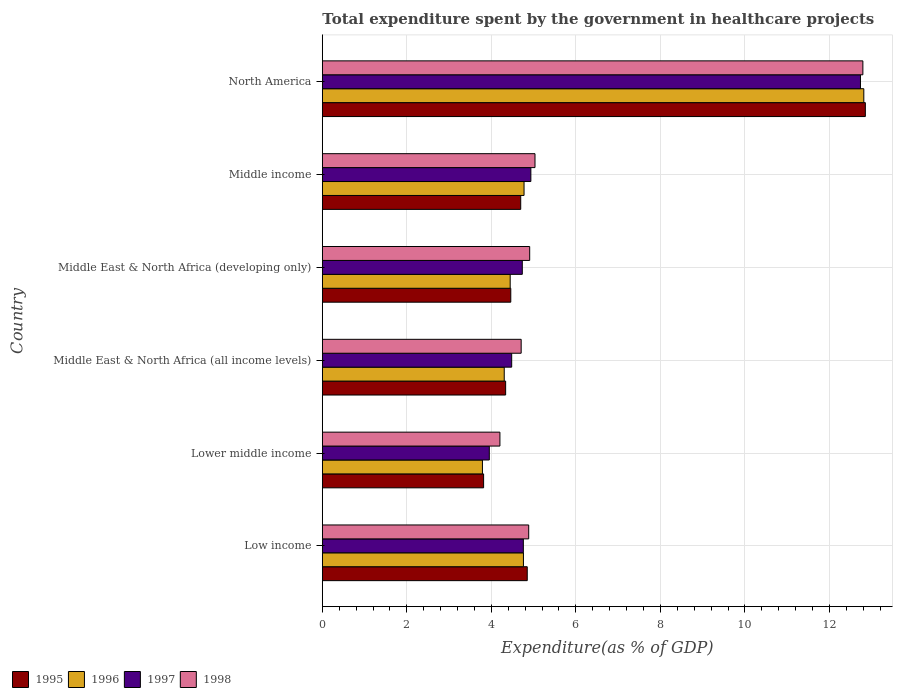How many different coloured bars are there?
Offer a terse response. 4. Are the number of bars on each tick of the Y-axis equal?
Make the answer very short. Yes. What is the label of the 4th group of bars from the top?
Provide a succinct answer. Middle East & North Africa (all income levels). In how many cases, is the number of bars for a given country not equal to the number of legend labels?
Keep it short and to the point. 0. What is the total expenditure spent by the government in healthcare projects in 1996 in North America?
Your answer should be very brief. 12.81. Across all countries, what is the maximum total expenditure spent by the government in healthcare projects in 1996?
Offer a terse response. 12.81. Across all countries, what is the minimum total expenditure spent by the government in healthcare projects in 1998?
Give a very brief answer. 4.2. In which country was the total expenditure spent by the government in healthcare projects in 1998 minimum?
Provide a succinct answer. Lower middle income. What is the total total expenditure spent by the government in healthcare projects in 1998 in the graph?
Your answer should be very brief. 36.52. What is the difference between the total expenditure spent by the government in healthcare projects in 1995 in Low income and that in Lower middle income?
Provide a short and direct response. 1.03. What is the difference between the total expenditure spent by the government in healthcare projects in 1996 in Lower middle income and the total expenditure spent by the government in healthcare projects in 1995 in North America?
Make the answer very short. -9.06. What is the average total expenditure spent by the government in healthcare projects in 1995 per country?
Your answer should be very brief. 5.83. What is the difference between the total expenditure spent by the government in healthcare projects in 1998 and total expenditure spent by the government in healthcare projects in 1996 in Middle East & North Africa (all income levels)?
Provide a short and direct response. 0.4. What is the ratio of the total expenditure spent by the government in healthcare projects in 1997 in Middle East & North Africa (all income levels) to that in Middle East & North Africa (developing only)?
Keep it short and to the point. 0.95. Is the total expenditure spent by the government in healthcare projects in 1997 in Middle East & North Africa (developing only) less than that in Middle income?
Offer a very short reply. Yes. Is the difference between the total expenditure spent by the government in healthcare projects in 1998 in Middle East & North Africa (developing only) and Middle income greater than the difference between the total expenditure spent by the government in healthcare projects in 1996 in Middle East & North Africa (developing only) and Middle income?
Keep it short and to the point. Yes. What is the difference between the highest and the second highest total expenditure spent by the government in healthcare projects in 1997?
Ensure brevity in your answer.  7.8. What is the difference between the highest and the lowest total expenditure spent by the government in healthcare projects in 1997?
Provide a succinct answer. 8.78. In how many countries, is the total expenditure spent by the government in healthcare projects in 1997 greater than the average total expenditure spent by the government in healthcare projects in 1997 taken over all countries?
Your response must be concise. 1. Is it the case that in every country, the sum of the total expenditure spent by the government in healthcare projects in 1997 and total expenditure spent by the government in healthcare projects in 1995 is greater than the sum of total expenditure spent by the government in healthcare projects in 1996 and total expenditure spent by the government in healthcare projects in 1998?
Your response must be concise. No. What does the 4th bar from the bottom in Middle East & North Africa (all income levels) represents?
Keep it short and to the point. 1998. Is it the case that in every country, the sum of the total expenditure spent by the government in healthcare projects in 1997 and total expenditure spent by the government in healthcare projects in 1996 is greater than the total expenditure spent by the government in healthcare projects in 1995?
Provide a succinct answer. Yes. How many bars are there?
Make the answer very short. 24. How many countries are there in the graph?
Provide a succinct answer. 6. Are the values on the major ticks of X-axis written in scientific E-notation?
Give a very brief answer. No. Where does the legend appear in the graph?
Ensure brevity in your answer.  Bottom left. How are the legend labels stacked?
Keep it short and to the point. Horizontal. What is the title of the graph?
Your answer should be compact. Total expenditure spent by the government in healthcare projects. What is the label or title of the X-axis?
Offer a terse response. Expenditure(as % of GDP). What is the Expenditure(as % of GDP) of 1995 in Low income?
Your answer should be compact. 4.85. What is the Expenditure(as % of GDP) of 1996 in Low income?
Your answer should be compact. 4.76. What is the Expenditure(as % of GDP) in 1997 in Low income?
Your answer should be very brief. 4.76. What is the Expenditure(as % of GDP) of 1998 in Low income?
Ensure brevity in your answer.  4.88. What is the Expenditure(as % of GDP) of 1995 in Lower middle income?
Your answer should be compact. 3.82. What is the Expenditure(as % of GDP) of 1996 in Lower middle income?
Your answer should be very brief. 3.79. What is the Expenditure(as % of GDP) in 1997 in Lower middle income?
Your answer should be very brief. 3.95. What is the Expenditure(as % of GDP) of 1998 in Lower middle income?
Ensure brevity in your answer.  4.2. What is the Expenditure(as % of GDP) in 1995 in Middle East & North Africa (all income levels)?
Provide a succinct answer. 4.34. What is the Expenditure(as % of GDP) in 1996 in Middle East & North Africa (all income levels)?
Ensure brevity in your answer.  4.3. What is the Expenditure(as % of GDP) of 1997 in Middle East & North Africa (all income levels)?
Give a very brief answer. 4.48. What is the Expenditure(as % of GDP) of 1998 in Middle East & North Africa (all income levels)?
Ensure brevity in your answer.  4.71. What is the Expenditure(as % of GDP) of 1995 in Middle East & North Africa (developing only)?
Your answer should be very brief. 4.46. What is the Expenditure(as % of GDP) in 1996 in Middle East & North Africa (developing only)?
Your answer should be very brief. 4.45. What is the Expenditure(as % of GDP) of 1997 in Middle East & North Africa (developing only)?
Keep it short and to the point. 4.73. What is the Expenditure(as % of GDP) in 1998 in Middle East & North Africa (developing only)?
Provide a succinct answer. 4.91. What is the Expenditure(as % of GDP) in 1995 in Middle income?
Keep it short and to the point. 4.69. What is the Expenditure(as % of GDP) of 1996 in Middle income?
Your response must be concise. 4.77. What is the Expenditure(as % of GDP) in 1997 in Middle income?
Make the answer very short. 4.93. What is the Expenditure(as % of GDP) in 1998 in Middle income?
Provide a short and direct response. 5.03. What is the Expenditure(as % of GDP) in 1995 in North America?
Your answer should be very brief. 12.85. What is the Expenditure(as % of GDP) of 1996 in North America?
Provide a short and direct response. 12.81. What is the Expenditure(as % of GDP) in 1997 in North America?
Offer a terse response. 12.73. What is the Expenditure(as % of GDP) of 1998 in North America?
Your answer should be compact. 12.79. Across all countries, what is the maximum Expenditure(as % of GDP) of 1995?
Provide a short and direct response. 12.85. Across all countries, what is the maximum Expenditure(as % of GDP) of 1996?
Your answer should be compact. 12.81. Across all countries, what is the maximum Expenditure(as % of GDP) of 1997?
Keep it short and to the point. 12.73. Across all countries, what is the maximum Expenditure(as % of GDP) of 1998?
Ensure brevity in your answer.  12.79. Across all countries, what is the minimum Expenditure(as % of GDP) of 1995?
Your response must be concise. 3.82. Across all countries, what is the minimum Expenditure(as % of GDP) of 1996?
Keep it short and to the point. 3.79. Across all countries, what is the minimum Expenditure(as % of GDP) in 1997?
Ensure brevity in your answer.  3.95. Across all countries, what is the minimum Expenditure(as % of GDP) in 1998?
Keep it short and to the point. 4.2. What is the total Expenditure(as % of GDP) in 1995 in the graph?
Give a very brief answer. 35.01. What is the total Expenditure(as % of GDP) of 1996 in the graph?
Your answer should be compact. 34.88. What is the total Expenditure(as % of GDP) in 1997 in the graph?
Provide a succinct answer. 35.59. What is the total Expenditure(as % of GDP) in 1998 in the graph?
Your answer should be compact. 36.52. What is the difference between the Expenditure(as % of GDP) of 1995 in Low income and that in Lower middle income?
Give a very brief answer. 1.03. What is the difference between the Expenditure(as % of GDP) in 1996 in Low income and that in Lower middle income?
Provide a succinct answer. 0.97. What is the difference between the Expenditure(as % of GDP) of 1997 in Low income and that in Lower middle income?
Give a very brief answer. 0.81. What is the difference between the Expenditure(as % of GDP) in 1998 in Low income and that in Lower middle income?
Make the answer very short. 0.68. What is the difference between the Expenditure(as % of GDP) of 1995 in Low income and that in Middle East & North Africa (all income levels)?
Provide a short and direct response. 0.51. What is the difference between the Expenditure(as % of GDP) of 1996 in Low income and that in Middle East & North Africa (all income levels)?
Keep it short and to the point. 0.45. What is the difference between the Expenditure(as % of GDP) in 1997 in Low income and that in Middle East & North Africa (all income levels)?
Ensure brevity in your answer.  0.28. What is the difference between the Expenditure(as % of GDP) in 1998 in Low income and that in Middle East & North Africa (all income levels)?
Your answer should be compact. 0.18. What is the difference between the Expenditure(as % of GDP) of 1995 in Low income and that in Middle East & North Africa (developing only)?
Provide a short and direct response. 0.39. What is the difference between the Expenditure(as % of GDP) of 1996 in Low income and that in Middle East & North Africa (developing only)?
Provide a short and direct response. 0.31. What is the difference between the Expenditure(as % of GDP) of 1997 in Low income and that in Middle East & North Africa (developing only)?
Give a very brief answer. 0.02. What is the difference between the Expenditure(as % of GDP) of 1998 in Low income and that in Middle East & North Africa (developing only)?
Offer a terse response. -0.02. What is the difference between the Expenditure(as % of GDP) of 1995 in Low income and that in Middle income?
Keep it short and to the point. 0.15. What is the difference between the Expenditure(as % of GDP) in 1996 in Low income and that in Middle income?
Provide a short and direct response. -0.01. What is the difference between the Expenditure(as % of GDP) in 1997 in Low income and that in Middle income?
Provide a succinct answer. -0.18. What is the difference between the Expenditure(as % of GDP) in 1998 in Low income and that in Middle income?
Make the answer very short. -0.15. What is the difference between the Expenditure(as % of GDP) of 1995 in Low income and that in North America?
Give a very brief answer. -8. What is the difference between the Expenditure(as % of GDP) of 1996 in Low income and that in North America?
Give a very brief answer. -8.05. What is the difference between the Expenditure(as % of GDP) of 1997 in Low income and that in North America?
Provide a succinct answer. -7.98. What is the difference between the Expenditure(as % of GDP) in 1998 in Low income and that in North America?
Your response must be concise. -7.91. What is the difference between the Expenditure(as % of GDP) of 1995 in Lower middle income and that in Middle East & North Africa (all income levels)?
Keep it short and to the point. -0.52. What is the difference between the Expenditure(as % of GDP) in 1996 in Lower middle income and that in Middle East & North Africa (all income levels)?
Make the answer very short. -0.52. What is the difference between the Expenditure(as % of GDP) in 1997 in Lower middle income and that in Middle East & North Africa (all income levels)?
Offer a very short reply. -0.53. What is the difference between the Expenditure(as % of GDP) in 1998 in Lower middle income and that in Middle East & North Africa (all income levels)?
Offer a terse response. -0.5. What is the difference between the Expenditure(as % of GDP) of 1995 in Lower middle income and that in Middle East & North Africa (developing only)?
Your answer should be compact. -0.64. What is the difference between the Expenditure(as % of GDP) in 1996 in Lower middle income and that in Middle East & North Africa (developing only)?
Keep it short and to the point. -0.66. What is the difference between the Expenditure(as % of GDP) of 1997 in Lower middle income and that in Middle East & North Africa (developing only)?
Give a very brief answer. -0.78. What is the difference between the Expenditure(as % of GDP) in 1998 in Lower middle income and that in Middle East & North Africa (developing only)?
Your response must be concise. -0.7. What is the difference between the Expenditure(as % of GDP) of 1995 in Lower middle income and that in Middle income?
Your response must be concise. -0.88. What is the difference between the Expenditure(as % of GDP) in 1996 in Lower middle income and that in Middle income?
Give a very brief answer. -0.98. What is the difference between the Expenditure(as % of GDP) in 1997 in Lower middle income and that in Middle income?
Provide a short and direct response. -0.98. What is the difference between the Expenditure(as % of GDP) of 1998 in Lower middle income and that in Middle income?
Offer a terse response. -0.83. What is the difference between the Expenditure(as % of GDP) in 1995 in Lower middle income and that in North America?
Make the answer very short. -9.03. What is the difference between the Expenditure(as % of GDP) in 1996 in Lower middle income and that in North America?
Ensure brevity in your answer.  -9.02. What is the difference between the Expenditure(as % of GDP) in 1997 in Lower middle income and that in North America?
Make the answer very short. -8.78. What is the difference between the Expenditure(as % of GDP) of 1998 in Lower middle income and that in North America?
Your response must be concise. -8.59. What is the difference between the Expenditure(as % of GDP) in 1995 in Middle East & North Africa (all income levels) and that in Middle East & North Africa (developing only)?
Your answer should be very brief. -0.12. What is the difference between the Expenditure(as % of GDP) of 1996 in Middle East & North Africa (all income levels) and that in Middle East & North Africa (developing only)?
Provide a succinct answer. -0.14. What is the difference between the Expenditure(as % of GDP) of 1997 in Middle East & North Africa (all income levels) and that in Middle East & North Africa (developing only)?
Keep it short and to the point. -0.25. What is the difference between the Expenditure(as % of GDP) in 1998 in Middle East & North Africa (all income levels) and that in Middle East & North Africa (developing only)?
Your response must be concise. -0.2. What is the difference between the Expenditure(as % of GDP) of 1995 in Middle East & North Africa (all income levels) and that in Middle income?
Your answer should be compact. -0.36. What is the difference between the Expenditure(as % of GDP) of 1996 in Middle East & North Africa (all income levels) and that in Middle income?
Your response must be concise. -0.47. What is the difference between the Expenditure(as % of GDP) in 1997 in Middle East & North Africa (all income levels) and that in Middle income?
Ensure brevity in your answer.  -0.45. What is the difference between the Expenditure(as % of GDP) in 1998 in Middle East & North Africa (all income levels) and that in Middle income?
Make the answer very short. -0.33. What is the difference between the Expenditure(as % of GDP) in 1995 in Middle East & North Africa (all income levels) and that in North America?
Your answer should be compact. -8.51. What is the difference between the Expenditure(as % of GDP) of 1996 in Middle East & North Africa (all income levels) and that in North America?
Your answer should be compact. -8.51. What is the difference between the Expenditure(as % of GDP) in 1997 in Middle East & North Africa (all income levels) and that in North America?
Ensure brevity in your answer.  -8.25. What is the difference between the Expenditure(as % of GDP) of 1998 in Middle East & North Africa (all income levels) and that in North America?
Offer a very short reply. -8.09. What is the difference between the Expenditure(as % of GDP) of 1995 in Middle East & North Africa (developing only) and that in Middle income?
Provide a short and direct response. -0.24. What is the difference between the Expenditure(as % of GDP) in 1996 in Middle East & North Africa (developing only) and that in Middle income?
Keep it short and to the point. -0.33. What is the difference between the Expenditure(as % of GDP) in 1997 in Middle East & North Africa (developing only) and that in Middle income?
Ensure brevity in your answer.  -0.2. What is the difference between the Expenditure(as % of GDP) of 1998 in Middle East & North Africa (developing only) and that in Middle income?
Provide a succinct answer. -0.13. What is the difference between the Expenditure(as % of GDP) of 1995 in Middle East & North Africa (developing only) and that in North America?
Give a very brief answer. -8.39. What is the difference between the Expenditure(as % of GDP) in 1996 in Middle East & North Africa (developing only) and that in North America?
Your response must be concise. -8.37. What is the difference between the Expenditure(as % of GDP) in 1997 in Middle East & North Africa (developing only) and that in North America?
Ensure brevity in your answer.  -8. What is the difference between the Expenditure(as % of GDP) of 1998 in Middle East & North Africa (developing only) and that in North America?
Provide a succinct answer. -7.88. What is the difference between the Expenditure(as % of GDP) of 1995 in Middle income and that in North America?
Keep it short and to the point. -8.15. What is the difference between the Expenditure(as % of GDP) of 1996 in Middle income and that in North America?
Ensure brevity in your answer.  -8.04. What is the difference between the Expenditure(as % of GDP) of 1997 in Middle income and that in North America?
Make the answer very short. -7.8. What is the difference between the Expenditure(as % of GDP) in 1998 in Middle income and that in North America?
Your answer should be compact. -7.76. What is the difference between the Expenditure(as % of GDP) in 1995 in Low income and the Expenditure(as % of GDP) in 1996 in Lower middle income?
Give a very brief answer. 1.06. What is the difference between the Expenditure(as % of GDP) of 1995 in Low income and the Expenditure(as % of GDP) of 1997 in Lower middle income?
Ensure brevity in your answer.  0.9. What is the difference between the Expenditure(as % of GDP) in 1995 in Low income and the Expenditure(as % of GDP) in 1998 in Lower middle income?
Your answer should be compact. 0.65. What is the difference between the Expenditure(as % of GDP) of 1996 in Low income and the Expenditure(as % of GDP) of 1997 in Lower middle income?
Give a very brief answer. 0.81. What is the difference between the Expenditure(as % of GDP) of 1996 in Low income and the Expenditure(as % of GDP) of 1998 in Lower middle income?
Offer a terse response. 0.56. What is the difference between the Expenditure(as % of GDP) of 1997 in Low income and the Expenditure(as % of GDP) of 1998 in Lower middle income?
Your answer should be very brief. 0.55. What is the difference between the Expenditure(as % of GDP) in 1995 in Low income and the Expenditure(as % of GDP) in 1996 in Middle East & North Africa (all income levels)?
Offer a very short reply. 0.54. What is the difference between the Expenditure(as % of GDP) in 1995 in Low income and the Expenditure(as % of GDP) in 1997 in Middle East & North Africa (all income levels)?
Offer a very short reply. 0.37. What is the difference between the Expenditure(as % of GDP) of 1995 in Low income and the Expenditure(as % of GDP) of 1998 in Middle East & North Africa (all income levels)?
Your answer should be very brief. 0.14. What is the difference between the Expenditure(as % of GDP) in 1996 in Low income and the Expenditure(as % of GDP) in 1997 in Middle East & North Africa (all income levels)?
Keep it short and to the point. 0.28. What is the difference between the Expenditure(as % of GDP) in 1996 in Low income and the Expenditure(as % of GDP) in 1998 in Middle East & North Africa (all income levels)?
Your response must be concise. 0.05. What is the difference between the Expenditure(as % of GDP) in 1997 in Low income and the Expenditure(as % of GDP) in 1998 in Middle East & North Africa (all income levels)?
Provide a short and direct response. 0.05. What is the difference between the Expenditure(as % of GDP) of 1995 in Low income and the Expenditure(as % of GDP) of 1996 in Middle East & North Africa (developing only)?
Make the answer very short. 0.4. What is the difference between the Expenditure(as % of GDP) in 1995 in Low income and the Expenditure(as % of GDP) in 1997 in Middle East & North Africa (developing only)?
Provide a short and direct response. 0.12. What is the difference between the Expenditure(as % of GDP) of 1995 in Low income and the Expenditure(as % of GDP) of 1998 in Middle East & North Africa (developing only)?
Your response must be concise. -0.06. What is the difference between the Expenditure(as % of GDP) of 1996 in Low income and the Expenditure(as % of GDP) of 1997 in Middle East & North Africa (developing only)?
Provide a short and direct response. 0.03. What is the difference between the Expenditure(as % of GDP) of 1996 in Low income and the Expenditure(as % of GDP) of 1998 in Middle East & North Africa (developing only)?
Ensure brevity in your answer.  -0.15. What is the difference between the Expenditure(as % of GDP) of 1997 in Low income and the Expenditure(as % of GDP) of 1998 in Middle East & North Africa (developing only)?
Provide a short and direct response. -0.15. What is the difference between the Expenditure(as % of GDP) in 1995 in Low income and the Expenditure(as % of GDP) in 1996 in Middle income?
Provide a short and direct response. 0.08. What is the difference between the Expenditure(as % of GDP) in 1995 in Low income and the Expenditure(as % of GDP) in 1997 in Middle income?
Keep it short and to the point. -0.09. What is the difference between the Expenditure(as % of GDP) of 1995 in Low income and the Expenditure(as % of GDP) of 1998 in Middle income?
Ensure brevity in your answer.  -0.18. What is the difference between the Expenditure(as % of GDP) of 1996 in Low income and the Expenditure(as % of GDP) of 1997 in Middle income?
Your response must be concise. -0.18. What is the difference between the Expenditure(as % of GDP) of 1996 in Low income and the Expenditure(as % of GDP) of 1998 in Middle income?
Your answer should be compact. -0.27. What is the difference between the Expenditure(as % of GDP) in 1997 in Low income and the Expenditure(as % of GDP) in 1998 in Middle income?
Your response must be concise. -0.28. What is the difference between the Expenditure(as % of GDP) of 1995 in Low income and the Expenditure(as % of GDP) of 1996 in North America?
Make the answer very short. -7.96. What is the difference between the Expenditure(as % of GDP) in 1995 in Low income and the Expenditure(as % of GDP) in 1997 in North America?
Ensure brevity in your answer.  -7.88. What is the difference between the Expenditure(as % of GDP) in 1995 in Low income and the Expenditure(as % of GDP) in 1998 in North America?
Offer a terse response. -7.94. What is the difference between the Expenditure(as % of GDP) in 1996 in Low income and the Expenditure(as % of GDP) in 1997 in North America?
Your answer should be very brief. -7.97. What is the difference between the Expenditure(as % of GDP) of 1996 in Low income and the Expenditure(as % of GDP) of 1998 in North America?
Your response must be concise. -8.03. What is the difference between the Expenditure(as % of GDP) of 1997 in Low income and the Expenditure(as % of GDP) of 1998 in North America?
Offer a very short reply. -8.03. What is the difference between the Expenditure(as % of GDP) of 1995 in Lower middle income and the Expenditure(as % of GDP) of 1996 in Middle East & North Africa (all income levels)?
Give a very brief answer. -0.49. What is the difference between the Expenditure(as % of GDP) of 1995 in Lower middle income and the Expenditure(as % of GDP) of 1997 in Middle East & North Africa (all income levels)?
Your answer should be very brief. -0.66. What is the difference between the Expenditure(as % of GDP) in 1995 in Lower middle income and the Expenditure(as % of GDP) in 1998 in Middle East & North Africa (all income levels)?
Your response must be concise. -0.89. What is the difference between the Expenditure(as % of GDP) in 1996 in Lower middle income and the Expenditure(as % of GDP) in 1997 in Middle East & North Africa (all income levels)?
Give a very brief answer. -0.69. What is the difference between the Expenditure(as % of GDP) in 1996 in Lower middle income and the Expenditure(as % of GDP) in 1998 in Middle East & North Africa (all income levels)?
Your response must be concise. -0.92. What is the difference between the Expenditure(as % of GDP) in 1997 in Lower middle income and the Expenditure(as % of GDP) in 1998 in Middle East & North Africa (all income levels)?
Give a very brief answer. -0.75. What is the difference between the Expenditure(as % of GDP) in 1995 in Lower middle income and the Expenditure(as % of GDP) in 1996 in Middle East & North Africa (developing only)?
Keep it short and to the point. -0.63. What is the difference between the Expenditure(as % of GDP) in 1995 in Lower middle income and the Expenditure(as % of GDP) in 1997 in Middle East & North Africa (developing only)?
Provide a short and direct response. -0.92. What is the difference between the Expenditure(as % of GDP) of 1995 in Lower middle income and the Expenditure(as % of GDP) of 1998 in Middle East & North Africa (developing only)?
Your answer should be very brief. -1.09. What is the difference between the Expenditure(as % of GDP) of 1996 in Lower middle income and the Expenditure(as % of GDP) of 1997 in Middle East & North Africa (developing only)?
Ensure brevity in your answer.  -0.94. What is the difference between the Expenditure(as % of GDP) of 1996 in Lower middle income and the Expenditure(as % of GDP) of 1998 in Middle East & North Africa (developing only)?
Provide a succinct answer. -1.12. What is the difference between the Expenditure(as % of GDP) in 1997 in Lower middle income and the Expenditure(as % of GDP) in 1998 in Middle East & North Africa (developing only)?
Keep it short and to the point. -0.96. What is the difference between the Expenditure(as % of GDP) of 1995 in Lower middle income and the Expenditure(as % of GDP) of 1996 in Middle income?
Your answer should be very brief. -0.96. What is the difference between the Expenditure(as % of GDP) of 1995 in Lower middle income and the Expenditure(as % of GDP) of 1997 in Middle income?
Ensure brevity in your answer.  -1.12. What is the difference between the Expenditure(as % of GDP) in 1995 in Lower middle income and the Expenditure(as % of GDP) in 1998 in Middle income?
Offer a very short reply. -1.22. What is the difference between the Expenditure(as % of GDP) in 1996 in Lower middle income and the Expenditure(as % of GDP) in 1997 in Middle income?
Your response must be concise. -1.15. What is the difference between the Expenditure(as % of GDP) in 1996 in Lower middle income and the Expenditure(as % of GDP) in 1998 in Middle income?
Offer a terse response. -1.24. What is the difference between the Expenditure(as % of GDP) in 1997 in Lower middle income and the Expenditure(as % of GDP) in 1998 in Middle income?
Your response must be concise. -1.08. What is the difference between the Expenditure(as % of GDP) in 1995 in Lower middle income and the Expenditure(as % of GDP) in 1996 in North America?
Provide a short and direct response. -9. What is the difference between the Expenditure(as % of GDP) of 1995 in Lower middle income and the Expenditure(as % of GDP) of 1997 in North America?
Your answer should be compact. -8.92. What is the difference between the Expenditure(as % of GDP) of 1995 in Lower middle income and the Expenditure(as % of GDP) of 1998 in North America?
Your answer should be compact. -8.97. What is the difference between the Expenditure(as % of GDP) in 1996 in Lower middle income and the Expenditure(as % of GDP) in 1997 in North America?
Your response must be concise. -8.95. What is the difference between the Expenditure(as % of GDP) in 1996 in Lower middle income and the Expenditure(as % of GDP) in 1998 in North America?
Your answer should be very brief. -9. What is the difference between the Expenditure(as % of GDP) in 1997 in Lower middle income and the Expenditure(as % of GDP) in 1998 in North America?
Your answer should be compact. -8.84. What is the difference between the Expenditure(as % of GDP) of 1995 in Middle East & North Africa (all income levels) and the Expenditure(as % of GDP) of 1996 in Middle East & North Africa (developing only)?
Give a very brief answer. -0.11. What is the difference between the Expenditure(as % of GDP) in 1995 in Middle East & North Africa (all income levels) and the Expenditure(as % of GDP) in 1997 in Middle East & North Africa (developing only)?
Offer a very short reply. -0.39. What is the difference between the Expenditure(as % of GDP) of 1995 in Middle East & North Africa (all income levels) and the Expenditure(as % of GDP) of 1998 in Middle East & North Africa (developing only)?
Provide a succinct answer. -0.57. What is the difference between the Expenditure(as % of GDP) of 1996 in Middle East & North Africa (all income levels) and the Expenditure(as % of GDP) of 1997 in Middle East & North Africa (developing only)?
Make the answer very short. -0.43. What is the difference between the Expenditure(as % of GDP) in 1996 in Middle East & North Africa (all income levels) and the Expenditure(as % of GDP) in 1998 in Middle East & North Africa (developing only)?
Your answer should be compact. -0.6. What is the difference between the Expenditure(as % of GDP) in 1997 in Middle East & North Africa (all income levels) and the Expenditure(as % of GDP) in 1998 in Middle East & North Africa (developing only)?
Offer a terse response. -0.43. What is the difference between the Expenditure(as % of GDP) in 1995 in Middle East & North Africa (all income levels) and the Expenditure(as % of GDP) in 1996 in Middle income?
Ensure brevity in your answer.  -0.44. What is the difference between the Expenditure(as % of GDP) in 1995 in Middle East & North Africa (all income levels) and the Expenditure(as % of GDP) in 1997 in Middle income?
Provide a succinct answer. -0.6. What is the difference between the Expenditure(as % of GDP) of 1995 in Middle East & North Africa (all income levels) and the Expenditure(as % of GDP) of 1998 in Middle income?
Provide a short and direct response. -0.69. What is the difference between the Expenditure(as % of GDP) in 1996 in Middle East & North Africa (all income levels) and the Expenditure(as % of GDP) in 1997 in Middle income?
Your response must be concise. -0.63. What is the difference between the Expenditure(as % of GDP) in 1996 in Middle East & North Africa (all income levels) and the Expenditure(as % of GDP) in 1998 in Middle income?
Provide a succinct answer. -0.73. What is the difference between the Expenditure(as % of GDP) in 1997 in Middle East & North Africa (all income levels) and the Expenditure(as % of GDP) in 1998 in Middle income?
Ensure brevity in your answer.  -0.55. What is the difference between the Expenditure(as % of GDP) in 1995 in Middle East & North Africa (all income levels) and the Expenditure(as % of GDP) in 1996 in North America?
Your answer should be very brief. -8.48. What is the difference between the Expenditure(as % of GDP) of 1995 in Middle East & North Africa (all income levels) and the Expenditure(as % of GDP) of 1997 in North America?
Give a very brief answer. -8.4. What is the difference between the Expenditure(as % of GDP) of 1995 in Middle East & North Africa (all income levels) and the Expenditure(as % of GDP) of 1998 in North America?
Provide a short and direct response. -8.45. What is the difference between the Expenditure(as % of GDP) in 1996 in Middle East & North Africa (all income levels) and the Expenditure(as % of GDP) in 1997 in North America?
Your answer should be very brief. -8.43. What is the difference between the Expenditure(as % of GDP) in 1996 in Middle East & North Africa (all income levels) and the Expenditure(as % of GDP) in 1998 in North America?
Your answer should be very brief. -8.49. What is the difference between the Expenditure(as % of GDP) in 1997 in Middle East & North Africa (all income levels) and the Expenditure(as % of GDP) in 1998 in North America?
Offer a very short reply. -8.31. What is the difference between the Expenditure(as % of GDP) in 1995 in Middle East & North Africa (developing only) and the Expenditure(as % of GDP) in 1996 in Middle income?
Keep it short and to the point. -0.31. What is the difference between the Expenditure(as % of GDP) of 1995 in Middle East & North Africa (developing only) and the Expenditure(as % of GDP) of 1997 in Middle income?
Offer a very short reply. -0.48. What is the difference between the Expenditure(as % of GDP) in 1995 in Middle East & North Africa (developing only) and the Expenditure(as % of GDP) in 1998 in Middle income?
Make the answer very short. -0.57. What is the difference between the Expenditure(as % of GDP) of 1996 in Middle East & North Africa (developing only) and the Expenditure(as % of GDP) of 1997 in Middle income?
Provide a short and direct response. -0.49. What is the difference between the Expenditure(as % of GDP) in 1996 in Middle East & North Africa (developing only) and the Expenditure(as % of GDP) in 1998 in Middle income?
Make the answer very short. -0.59. What is the difference between the Expenditure(as % of GDP) in 1997 in Middle East & North Africa (developing only) and the Expenditure(as % of GDP) in 1998 in Middle income?
Offer a very short reply. -0.3. What is the difference between the Expenditure(as % of GDP) in 1995 in Middle East & North Africa (developing only) and the Expenditure(as % of GDP) in 1996 in North America?
Give a very brief answer. -8.35. What is the difference between the Expenditure(as % of GDP) in 1995 in Middle East & North Africa (developing only) and the Expenditure(as % of GDP) in 1997 in North America?
Your answer should be compact. -8.27. What is the difference between the Expenditure(as % of GDP) in 1995 in Middle East & North Africa (developing only) and the Expenditure(as % of GDP) in 1998 in North America?
Provide a succinct answer. -8.33. What is the difference between the Expenditure(as % of GDP) of 1996 in Middle East & North Africa (developing only) and the Expenditure(as % of GDP) of 1997 in North America?
Offer a terse response. -8.29. What is the difference between the Expenditure(as % of GDP) in 1996 in Middle East & North Africa (developing only) and the Expenditure(as % of GDP) in 1998 in North America?
Give a very brief answer. -8.35. What is the difference between the Expenditure(as % of GDP) in 1997 in Middle East & North Africa (developing only) and the Expenditure(as % of GDP) in 1998 in North America?
Provide a short and direct response. -8.06. What is the difference between the Expenditure(as % of GDP) in 1995 in Middle income and the Expenditure(as % of GDP) in 1996 in North America?
Your answer should be very brief. -8.12. What is the difference between the Expenditure(as % of GDP) in 1995 in Middle income and the Expenditure(as % of GDP) in 1997 in North America?
Make the answer very short. -8.04. What is the difference between the Expenditure(as % of GDP) of 1995 in Middle income and the Expenditure(as % of GDP) of 1998 in North America?
Make the answer very short. -8.1. What is the difference between the Expenditure(as % of GDP) of 1996 in Middle income and the Expenditure(as % of GDP) of 1997 in North America?
Offer a very short reply. -7.96. What is the difference between the Expenditure(as % of GDP) in 1996 in Middle income and the Expenditure(as % of GDP) in 1998 in North America?
Give a very brief answer. -8.02. What is the difference between the Expenditure(as % of GDP) of 1997 in Middle income and the Expenditure(as % of GDP) of 1998 in North America?
Offer a very short reply. -7.86. What is the average Expenditure(as % of GDP) of 1995 per country?
Your response must be concise. 5.83. What is the average Expenditure(as % of GDP) in 1996 per country?
Your answer should be very brief. 5.81. What is the average Expenditure(as % of GDP) of 1997 per country?
Keep it short and to the point. 5.93. What is the average Expenditure(as % of GDP) in 1998 per country?
Provide a succinct answer. 6.09. What is the difference between the Expenditure(as % of GDP) of 1995 and Expenditure(as % of GDP) of 1996 in Low income?
Give a very brief answer. 0.09. What is the difference between the Expenditure(as % of GDP) of 1995 and Expenditure(as % of GDP) of 1997 in Low income?
Offer a very short reply. 0.09. What is the difference between the Expenditure(as % of GDP) of 1995 and Expenditure(as % of GDP) of 1998 in Low income?
Keep it short and to the point. -0.03. What is the difference between the Expenditure(as % of GDP) of 1996 and Expenditure(as % of GDP) of 1997 in Low income?
Offer a terse response. 0. What is the difference between the Expenditure(as % of GDP) in 1996 and Expenditure(as % of GDP) in 1998 in Low income?
Ensure brevity in your answer.  -0.12. What is the difference between the Expenditure(as % of GDP) in 1997 and Expenditure(as % of GDP) in 1998 in Low income?
Offer a very short reply. -0.13. What is the difference between the Expenditure(as % of GDP) in 1995 and Expenditure(as % of GDP) in 1996 in Lower middle income?
Provide a succinct answer. 0.03. What is the difference between the Expenditure(as % of GDP) of 1995 and Expenditure(as % of GDP) of 1997 in Lower middle income?
Provide a succinct answer. -0.14. What is the difference between the Expenditure(as % of GDP) of 1995 and Expenditure(as % of GDP) of 1998 in Lower middle income?
Offer a terse response. -0.39. What is the difference between the Expenditure(as % of GDP) of 1996 and Expenditure(as % of GDP) of 1997 in Lower middle income?
Ensure brevity in your answer.  -0.16. What is the difference between the Expenditure(as % of GDP) of 1996 and Expenditure(as % of GDP) of 1998 in Lower middle income?
Your response must be concise. -0.41. What is the difference between the Expenditure(as % of GDP) in 1997 and Expenditure(as % of GDP) in 1998 in Lower middle income?
Your response must be concise. -0.25. What is the difference between the Expenditure(as % of GDP) in 1995 and Expenditure(as % of GDP) in 1996 in Middle East & North Africa (all income levels)?
Your response must be concise. 0.03. What is the difference between the Expenditure(as % of GDP) in 1995 and Expenditure(as % of GDP) in 1997 in Middle East & North Africa (all income levels)?
Keep it short and to the point. -0.14. What is the difference between the Expenditure(as % of GDP) of 1995 and Expenditure(as % of GDP) of 1998 in Middle East & North Africa (all income levels)?
Your response must be concise. -0.37. What is the difference between the Expenditure(as % of GDP) in 1996 and Expenditure(as % of GDP) in 1997 in Middle East & North Africa (all income levels)?
Provide a short and direct response. -0.18. What is the difference between the Expenditure(as % of GDP) in 1996 and Expenditure(as % of GDP) in 1998 in Middle East & North Africa (all income levels)?
Your answer should be compact. -0.4. What is the difference between the Expenditure(as % of GDP) of 1997 and Expenditure(as % of GDP) of 1998 in Middle East & North Africa (all income levels)?
Your response must be concise. -0.22. What is the difference between the Expenditure(as % of GDP) in 1995 and Expenditure(as % of GDP) in 1996 in Middle East & North Africa (developing only)?
Your response must be concise. 0.01. What is the difference between the Expenditure(as % of GDP) of 1995 and Expenditure(as % of GDP) of 1997 in Middle East & North Africa (developing only)?
Give a very brief answer. -0.27. What is the difference between the Expenditure(as % of GDP) in 1995 and Expenditure(as % of GDP) in 1998 in Middle East & North Africa (developing only)?
Your answer should be very brief. -0.45. What is the difference between the Expenditure(as % of GDP) of 1996 and Expenditure(as % of GDP) of 1997 in Middle East & North Africa (developing only)?
Offer a terse response. -0.29. What is the difference between the Expenditure(as % of GDP) in 1996 and Expenditure(as % of GDP) in 1998 in Middle East & North Africa (developing only)?
Offer a very short reply. -0.46. What is the difference between the Expenditure(as % of GDP) in 1997 and Expenditure(as % of GDP) in 1998 in Middle East & North Africa (developing only)?
Your answer should be very brief. -0.17. What is the difference between the Expenditure(as % of GDP) of 1995 and Expenditure(as % of GDP) of 1996 in Middle income?
Give a very brief answer. -0.08. What is the difference between the Expenditure(as % of GDP) of 1995 and Expenditure(as % of GDP) of 1997 in Middle income?
Ensure brevity in your answer.  -0.24. What is the difference between the Expenditure(as % of GDP) in 1995 and Expenditure(as % of GDP) in 1998 in Middle income?
Your answer should be very brief. -0.34. What is the difference between the Expenditure(as % of GDP) of 1996 and Expenditure(as % of GDP) of 1997 in Middle income?
Offer a terse response. -0.16. What is the difference between the Expenditure(as % of GDP) of 1996 and Expenditure(as % of GDP) of 1998 in Middle income?
Your answer should be compact. -0.26. What is the difference between the Expenditure(as % of GDP) of 1997 and Expenditure(as % of GDP) of 1998 in Middle income?
Make the answer very short. -0.1. What is the difference between the Expenditure(as % of GDP) in 1995 and Expenditure(as % of GDP) in 1996 in North America?
Your answer should be very brief. 0.04. What is the difference between the Expenditure(as % of GDP) in 1995 and Expenditure(as % of GDP) in 1997 in North America?
Offer a terse response. 0.12. What is the difference between the Expenditure(as % of GDP) of 1995 and Expenditure(as % of GDP) of 1998 in North America?
Provide a short and direct response. 0.06. What is the difference between the Expenditure(as % of GDP) in 1996 and Expenditure(as % of GDP) in 1997 in North America?
Your response must be concise. 0.08. What is the difference between the Expenditure(as % of GDP) in 1996 and Expenditure(as % of GDP) in 1998 in North America?
Offer a terse response. 0.02. What is the difference between the Expenditure(as % of GDP) of 1997 and Expenditure(as % of GDP) of 1998 in North America?
Your response must be concise. -0.06. What is the ratio of the Expenditure(as % of GDP) in 1995 in Low income to that in Lower middle income?
Your answer should be very brief. 1.27. What is the ratio of the Expenditure(as % of GDP) in 1996 in Low income to that in Lower middle income?
Your response must be concise. 1.26. What is the ratio of the Expenditure(as % of GDP) in 1997 in Low income to that in Lower middle income?
Provide a short and direct response. 1.2. What is the ratio of the Expenditure(as % of GDP) of 1998 in Low income to that in Lower middle income?
Your response must be concise. 1.16. What is the ratio of the Expenditure(as % of GDP) of 1995 in Low income to that in Middle East & North Africa (all income levels)?
Ensure brevity in your answer.  1.12. What is the ratio of the Expenditure(as % of GDP) in 1996 in Low income to that in Middle East & North Africa (all income levels)?
Your response must be concise. 1.11. What is the ratio of the Expenditure(as % of GDP) in 1997 in Low income to that in Middle East & North Africa (all income levels)?
Give a very brief answer. 1.06. What is the ratio of the Expenditure(as % of GDP) in 1998 in Low income to that in Middle East & North Africa (all income levels)?
Keep it short and to the point. 1.04. What is the ratio of the Expenditure(as % of GDP) of 1995 in Low income to that in Middle East & North Africa (developing only)?
Make the answer very short. 1.09. What is the ratio of the Expenditure(as % of GDP) of 1996 in Low income to that in Middle East & North Africa (developing only)?
Give a very brief answer. 1.07. What is the ratio of the Expenditure(as % of GDP) in 1997 in Low income to that in Middle East & North Africa (developing only)?
Your answer should be very brief. 1.01. What is the ratio of the Expenditure(as % of GDP) of 1995 in Low income to that in Middle income?
Provide a short and direct response. 1.03. What is the ratio of the Expenditure(as % of GDP) in 1996 in Low income to that in Middle income?
Ensure brevity in your answer.  1. What is the ratio of the Expenditure(as % of GDP) of 1998 in Low income to that in Middle income?
Your answer should be compact. 0.97. What is the ratio of the Expenditure(as % of GDP) of 1995 in Low income to that in North America?
Ensure brevity in your answer.  0.38. What is the ratio of the Expenditure(as % of GDP) in 1996 in Low income to that in North America?
Offer a terse response. 0.37. What is the ratio of the Expenditure(as % of GDP) in 1997 in Low income to that in North America?
Give a very brief answer. 0.37. What is the ratio of the Expenditure(as % of GDP) in 1998 in Low income to that in North America?
Your response must be concise. 0.38. What is the ratio of the Expenditure(as % of GDP) in 1995 in Lower middle income to that in Middle East & North Africa (all income levels)?
Your answer should be very brief. 0.88. What is the ratio of the Expenditure(as % of GDP) in 1996 in Lower middle income to that in Middle East & North Africa (all income levels)?
Provide a succinct answer. 0.88. What is the ratio of the Expenditure(as % of GDP) of 1997 in Lower middle income to that in Middle East & North Africa (all income levels)?
Your answer should be compact. 0.88. What is the ratio of the Expenditure(as % of GDP) in 1998 in Lower middle income to that in Middle East & North Africa (all income levels)?
Provide a short and direct response. 0.89. What is the ratio of the Expenditure(as % of GDP) in 1995 in Lower middle income to that in Middle East & North Africa (developing only)?
Ensure brevity in your answer.  0.86. What is the ratio of the Expenditure(as % of GDP) in 1996 in Lower middle income to that in Middle East & North Africa (developing only)?
Provide a short and direct response. 0.85. What is the ratio of the Expenditure(as % of GDP) of 1997 in Lower middle income to that in Middle East & North Africa (developing only)?
Make the answer very short. 0.84. What is the ratio of the Expenditure(as % of GDP) of 1998 in Lower middle income to that in Middle East & North Africa (developing only)?
Make the answer very short. 0.86. What is the ratio of the Expenditure(as % of GDP) of 1995 in Lower middle income to that in Middle income?
Make the answer very short. 0.81. What is the ratio of the Expenditure(as % of GDP) in 1996 in Lower middle income to that in Middle income?
Offer a very short reply. 0.79. What is the ratio of the Expenditure(as % of GDP) in 1997 in Lower middle income to that in Middle income?
Provide a succinct answer. 0.8. What is the ratio of the Expenditure(as % of GDP) in 1998 in Lower middle income to that in Middle income?
Provide a succinct answer. 0.84. What is the ratio of the Expenditure(as % of GDP) of 1995 in Lower middle income to that in North America?
Offer a terse response. 0.3. What is the ratio of the Expenditure(as % of GDP) in 1996 in Lower middle income to that in North America?
Ensure brevity in your answer.  0.3. What is the ratio of the Expenditure(as % of GDP) in 1997 in Lower middle income to that in North America?
Provide a succinct answer. 0.31. What is the ratio of the Expenditure(as % of GDP) in 1998 in Lower middle income to that in North America?
Offer a very short reply. 0.33. What is the ratio of the Expenditure(as % of GDP) in 1995 in Middle East & North Africa (all income levels) to that in Middle East & North Africa (developing only)?
Offer a terse response. 0.97. What is the ratio of the Expenditure(as % of GDP) in 1996 in Middle East & North Africa (all income levels) to that in Middle East & North Africa (developing only)?
Give a very brief answer. 0.97. What is the ratio of the Expenditure(as % of GDP) in 1997 in Middle East & North Africa (all income levels) to that in Middle East & North Africa (developing only)?
Provide a short and direct response. 0.95. What is the ratio of the Expenditure(as % of GDP) of 1998 in Middle East & North Africa (all income levels) to that in Middle East & North Africa (developing only)?
Ensure brevity in your answer.  0.96. What is the ratio of the Expenditure(as % of GDP) of 1995 in Middle East & North Africa (all income levels) to that in Middle income?
Provide a succinct answer. 0.92. What is the ratio of the Expenditure(as % of GDP) of 1996 in Middle East & North Africa (all income levels) to that in Middle income?
Keep it short and to the point. 0.9. What is the ratio of the Expenditure(as % of GDP) in 1997 in Middle East & North Africa (all income levels) to that in Middle income?
Ensure brevity in your answer.  0.91. What is the ratio of the Expenditure(as % of GDP) in 1998 in Middle East & North Africa (all income levels) to that in Middle income?
Give a very brief answer. 0.94. What is the ratio of the Expenditure(as % of GDP) in 1995 in Middle East & North Africa (all income levels) to that in North America?
Provide a succinct answer. 0.34. What is the ratio of the Expenditure(as % of GDP) of 1996 in Middle East & North Africa (all income levels) to that in North America?
Ensure brevity in your answer.  0.34. What is the ratio of the Expenditure(as % of GDP) in 1997 in Middle East & North Africa (all income levels) to that in North America?
Offer a terse response. 0.35. What is the ratio of the Expenditure(as % of GDP) in 1998 in Middle East & North Africa (all income levels) to that in North America?
Your response must be concise. 0.37. What is the ratio of the Expenditure(as % of GDP) of 1995 in Middle East & North Africa (developing only) to that in Middle income?
Keep it short and to the point. 0.95. What is the ratio of the Expenditure(as % of GDP) of 1996 in Middle East & North Africa (developing only) to that in Middle income?
Your response must be concise. 0.93. What is the ratio of the Expenditure(as % of GDP) of 1997 in Middle East & North Africa (developing only) to that in Middle income?
Offer a very short reply. 0.96. What is the ratio of the Expenditure(as % of GDP) in 1995 in Middle East & North Africa (developing only) to that in North America?
Offer a terse response. 0.35. What is the ratio of the Expenditure(as % of GDP) of 1996 in Middle East & North Africa (developing only) to that in North America?
Offer a very short reply. 0.35. What is the ratio of the Expenditure(as % of GDP) in 1997 in Middle East & North Africa (developing only) to that in North America?
Your answer should be compact. 0.37. What is the ratio of the Expenditure(as % of GDP) of 1998 in Middle East & North Africa (developing only) to that in North America?
Keep it short and to the point. 0.38. What is the ratio of the Expenditure(as % of GDP) in 1995 in Middle income to that in North America?
Your response must be concise. 0.37. What is the ratio of the Expenditure(as % of GDP) of 1996 in Middle income to that in North America?
Keep it short and to the point. 0.37. What is the ratio of the Expenditure(as % of GDP) of 1997 in Middle income to that in North America?
Your response must be concise. 0.39. What is the ratio of the Expenditure(as % of GDP) in 1998 in Middle income to that in North America?
Keep it short and to the point. 0.39. What is the difference between the highest and the second highest Expenditure(as % of GDP) of 1995?
Provide a succinct answer. 8. What is the difference between the highest and the second highest Expenditure(as % of GDP) of 1996?
Give a very brief answer. 8.04. What is the difference between the highest and the second highest Expenditure(as % of GDP) of 1997?
Offer a terse response. 7.8. What is the difference between the highest and the second highest Expenditure(as % of GDP) of 1998?
Provide a short and direct response. 7.76. What is the difference between the highest and the lowest Expenditure(as % of GDP) of 1995?
Provide a short and direct response. 9.03. What is the difference between the highest and the lowest Expenditure(as % of GDP) in 1996?
Your response must be concise. 9.02. What is the difference between the highest and the lowest Expenditure(as % of GDP) in 1997?
Keep it short and to the point. 8.78. What is the difference between the highest and the lowest Expenditure(as % of GDP) in 1998?
Make the answer very short. 8.59. 